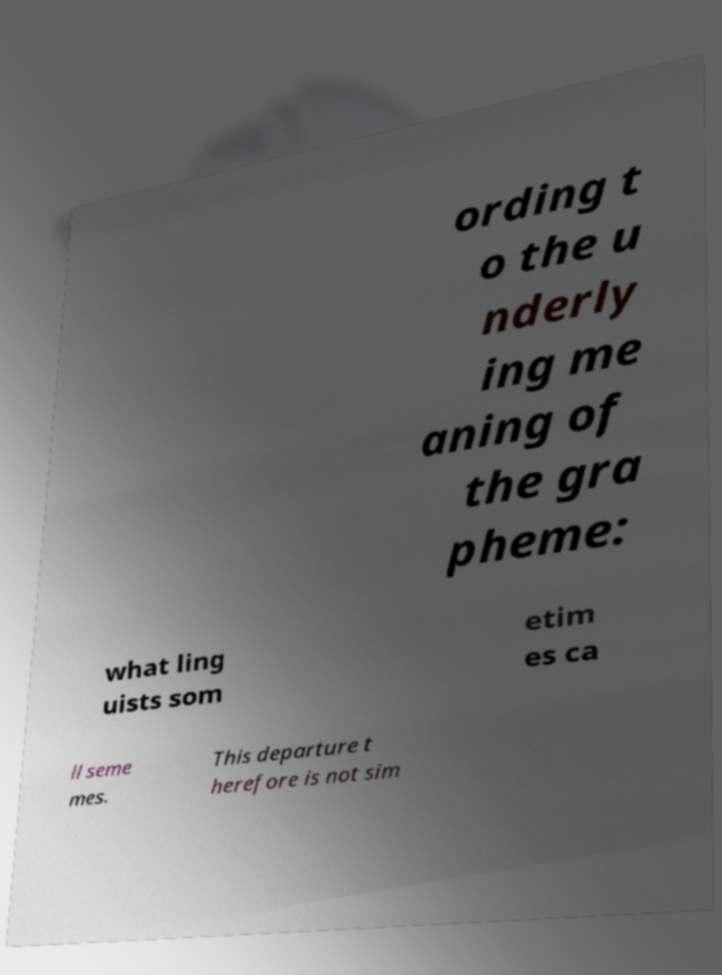There's text embedded in this image that I need extracted. Can you transcribe it verbatim? ording t o the u nderly ing me aning of the gra pheme: what ling uists som etim es ca ll seme mes. This departure t herefore is not sim 